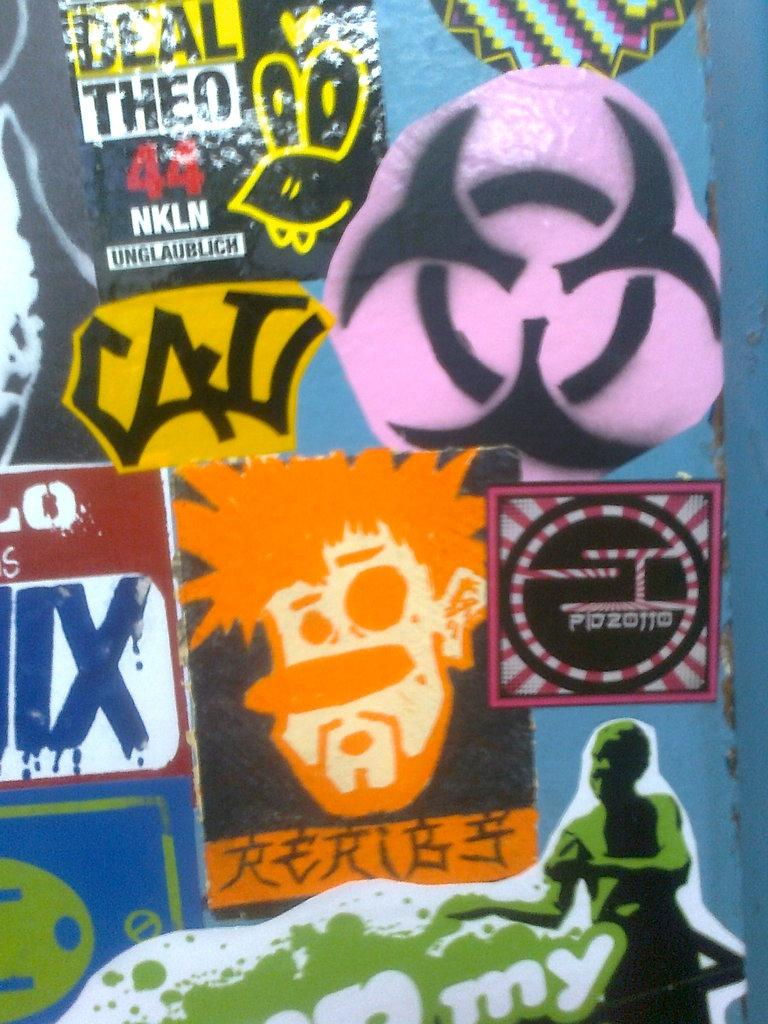What is the main subject in the center of the image? There is a poster in the center of the image. What is depicted on the poster? The poster contains a human face. Are there any words or phrases on the poster? Yes, there is writing on the poster. What type of stocking is the farmer wearing in the image? There is no farmer or stocking present in the image; it features a poster with a human face and writing. 